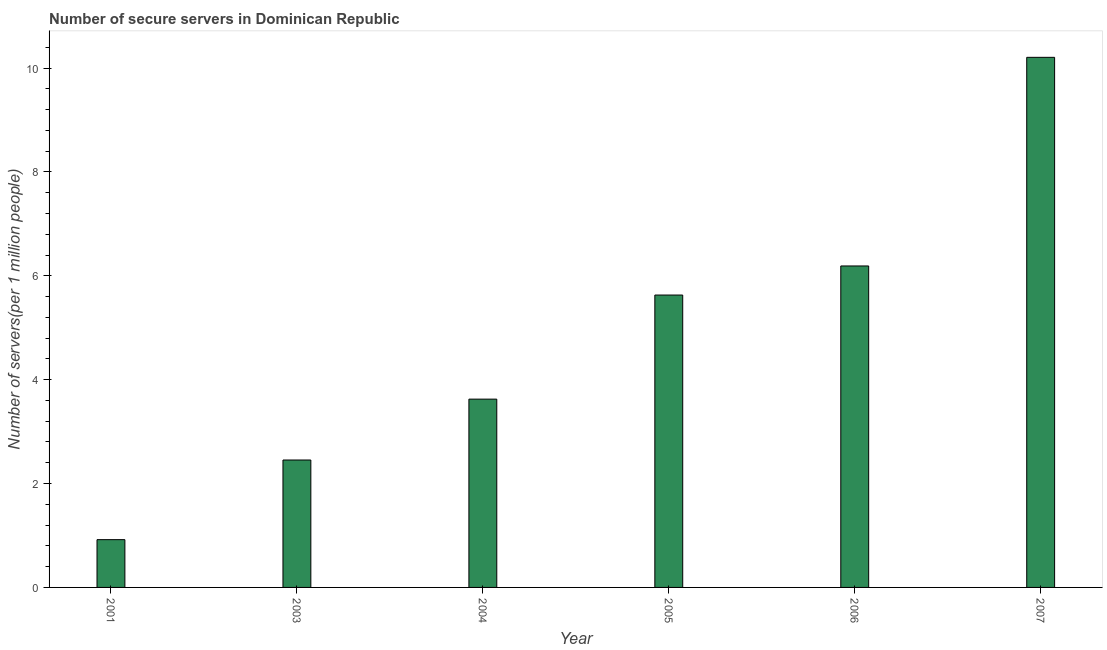Does the graph contain any zero values?
Keep it short and to the point. No. Does the graph contain grids?
Provide a short and direct response. No. What is the title of the graph?
Ensure brevity in your answer.  Number of secure servers in Dominican Republic. What is the label or title of the X-axis?
Offer a terse response. Year. What is the label or title of the Y-axis?
Your answer should be very brief. Number of servers(per 1 million people). What is the number of secure internet servers in 2005?
Your answer should be very brief. 5.63. Across all years, what is the maximum number of secure internet servers?
Your answer should be very brief. 10.21. Across all years, what is the minimum number of secure internet servers?
Provide a short and direct response. 0.92. In which year was the number of secure internet servers maximum?
Your response must be concise. 2007. What is the sum of the number of secure internet servers?
Offer a very short reply. 29.02. What is the difference between the number of secure internet servers in 2004 and 2006?
Provide a succinct answer. -2.56. What is the average number of secure internet servers per year?
Ensure brevity in your answer.  4.84. What is the median number of secure internet servers?
Make the answer very short. 4.63. What is the ratio of the number of secure internet servers in 2001 to that in 2004?
Offer a very short reply. 0.25. What is the difference between the highest and the second highest number of secure internet servers?
Give a very brief answer. 4.02. Is the sum of the number of secure internet servers in 2004 and 2007 greater than the maximum number of secure internet servers across all years?
Offer a very short reply. Yes. What is the difference between the highest and the lowest number of secure internet servers?
Provide a short and direct response. 9.29. How many years are there in the graph?
Provide a short and direct response. 6. What is the Number of servers(per 1 million people) of 2001?
Ensure brevity in your answer.  0.92. What is the Number of servers(per 1 million people) of 2003?
Keep it short and to the point. 2.45. What is the Number of servers(per 1 million people) in 2004?
Give a very brief answer. 3.63. What is the Number of servers(per 1 million people) in 2005?
Keep it short and to the point. 5.63. What is the Number of servers(per 1 million people) in 2006?
Make the answer very short. 6.19. What is the Number of servers(per 1 million people) of 2007?
Make the answer very short. 10.21. What is the difference between the Number of servers(per 1 million people) in 2001 and 2003?
Make the answer very short. -1.53. What is the difference between the Number of servers(per 1 million people) in 2001 and 2004?
Keep it short and to the point. -2.71. What is the difference between the Number of servers(per 1 million people) in 2001 and 2005?
Offer a very short reply. -4.71. What is the difference between the Number of servers(per 1 million people) in 2001 and 2006?
Keep it short and to the point. -5.27. What is the difference between the Number of servers(per 1 million people) in 2001 and 2007?
Your answer should be compact. -9.29. What is the difference between the Number of servers(per 1 million people) in 2003 and 2004?
Make the answer very short. -1.17. What is the difference between the Number of servers(per 1 million people) in 2003 and 2005?
Provide a succinct answer. -3.18. What is the difference between the Number of servers(per 1 million people) in 2003 and 2006?
Your response must be concise. -3.74. What is the difference between the Number of servers(per 1 million people) in 2003 and 2007?
Ensure brevity in your answer.  -7.75. What is the difference between the Number of servers(per 1 million people) in 2004 and 2005?
Give a very brief answer. -2. What is the difference between the Number of servers(per 1 million people) in 2004 and 2006?
Offer a terse response. -2.56. What is the difference between the Number of servers(per 1 million people) in 2004 and 2007?
Your answer should be very brief. -6.58. What is the difference between the Number of servers(per 1 million people) in 2005 and 2006?
Provide a succinct answer. -0.56. What is the difference between the Number of servers(per 1 million people) in 2005 and 2007?
Your response must be concise. -4.58. What is the difference between the Number of servers(per 1 million people) in 2006 and 2007?
Make the answer very short. -4.02. What is the ratio of the Number of servers(per 1 million people) in 2001 to that in 2004?
Make the answer very short. 0.25. What is the ratio of the Number of servers(per 1 million people) in 2001 to that in 2005?
Your answer should be very brief. 0.16. What is the ratio of the Number of servers(per 1 million people) in 2001 to that in 2006?
Keep it short and to the point. 0.15. What is the ratio of the Number of servers(per 1 million people) in 2001 to that in 2007?
Offer a terse response. 0.09. What is the ratio of the Number of servers(per 1 million people) in 2003 to that in 2004?
Make the answer very short. 0.68. What is the ratio of the Number of servers(per 1 million people) in 2003 to that in 2005?
Offer a terse response. 0.44. What is the ratio of the Number of servers(per 1 million people) in 2003 to that in 2006?
Your response must be concise. 0.4. What is the ratio of the Number of servers(per 1 million people) in 2003 to that in 2007?
Make the answer very short. 0.24. What is the ratio of the Number of servers(per 1 million people) in 2004 to that in 2005?
Provide a short and direct response. 0.64. What is the ratio of the Number of servers(per 1 million people) in 2004 to that in 2006?
Provide a short and direct response. 0.59. What is the ratio of the Number of servers(per 1 million people) in 2004 to that in 2007?
Your response must be concise. 0.35. What is the ratio of the Number of servers(per 1 million people) in 2005 to that in 2006?
Make the answer very short. 0.91. What is the ratio of the Number of servers(per 1 million people) in 2005 to that in 2007?
Keep it short and to the point. 0.55. What is the ratio of the Number of servers(per 1 million people) in 2006 to that in 2007?
Ensure brevity in your answer.  0.61. 